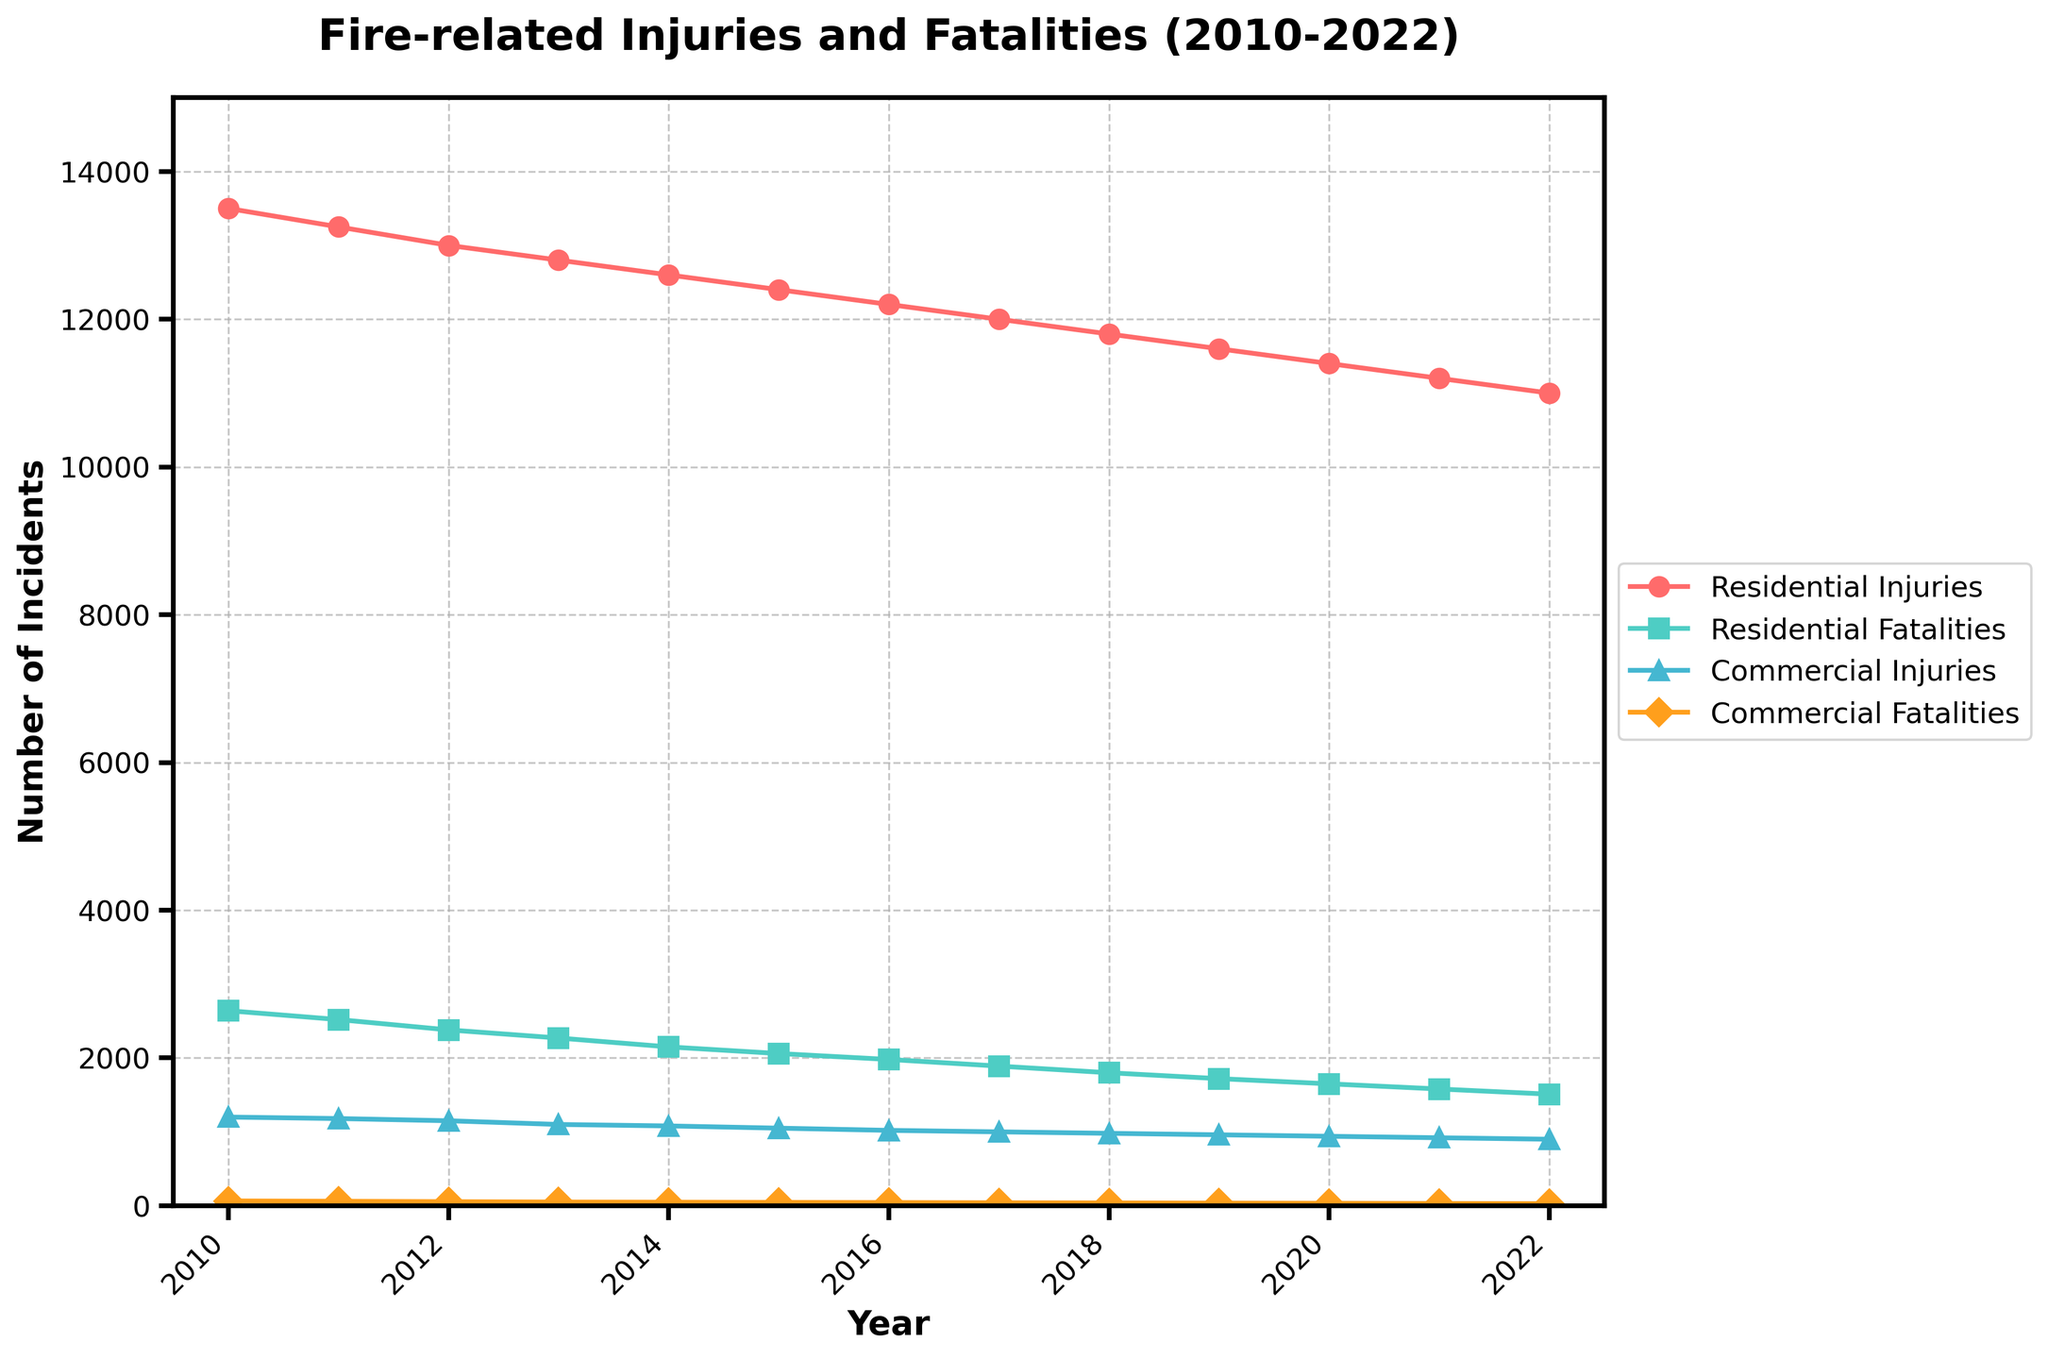How do the residential injuries in 2022 compare to those in 2010? To answer this, observe the values for residential injuries in the figure for 2022 and 2010. In 2010, there were 13500 residential injuries, while in 2022 there were 11000. So, compare these values directly.
Answer: Injuries decreased by 2500 Which category showed the smallest number of incidents in 2014? Look at the values for all categories in 2014 and identify the one with the smallest number. Residential Injuries (12600), Residential Fatalities (2150), Commercial Injuries (1080), and Commercial Fatalities (48). The smallest number is 48 for commercial fatalities.
Answer: Commercial Fatalities What's the average number of commercial injuries from 2010 to 2014? Add the values for commercial injuries from 2010 to 2014 and then divide by the number of years (5). (1200 + 1180 + 1150 + 1100 + 1080) = 5710. Then 5710 / 5 = 1142.
Answer: 1142 In which year did residential fatalities first drop below 2000? Look at the trend line for residential fatalities and identify the first year where the value is below 2000. The value first drops to 1980 in 2016.
Answer: 2016 How many more residential injuries were there than commercial injuries in 2013? Subtract the number of commercial injuries in 2013 from the number of residential injuries in 2013. Residential Injuries (12800) - Commercial Injuries (1100) = 11700.
Answer: 11700 Which year had the highest number of commercial fatalities? Observe the trend line for commercial fatalities and identify the year with the highest value. The highest value is in the year 2010 with 65 fatalities.
Answer: 2010 Calculate the decrease in residential fatalities from 2010 to 2022. Subtract residential fatalities in 2022 from those in 2010. The fatalities in 2010 are 2640 and in 2022 are 1510. 2640 - 1510 = 1130.
Answer: 1130 What trend do you observe in the number of commercial injuries from 2010 to 2022? Observe the line for commercial injuries across the years. Notice the consistent downward trend from 1200 in 2010 to 900 in 2022.
Answer: Consistent decrease Compare the slopes of the lines representing residential fatalities and commercial fatalities. Which one is steeper? Visually compare the downward trends of the lines for residential fatalities and commercial fatalities. The residential fatalities line shows a steeper decline from 2640 to 1510, whereas commercial fatalities decline from 65 to 28.
Answer: Residential Fatalities Which category showed a consistent downward trend without any increase from 2010 to 2022? Identify the lines for each category and determine which one never increases across the years. Both residential and commercial injuries and fatalities exhibit consistent downward trends.
Answer: All categories 